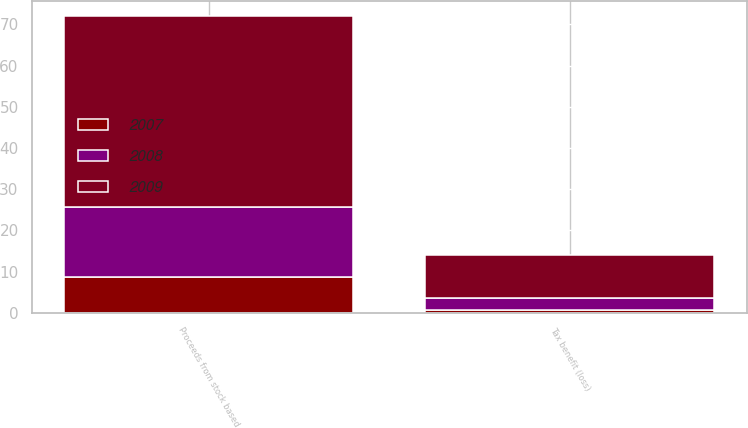Convert chart to OTSL. <chart><loc_0><loc_0><loc_500><loc_500><stacked_bar_chart><ecel><fcel>Proceeds from stock based<fcel>Tax benefit (loss)<nl><fcel>2007<fcel>8.7<fcel>0.7<nl><fcel>2008<fcel>17.1<fcel>3<nl><fcel>2009<fcel>46.3<fcel>10.4<nl></chart> 